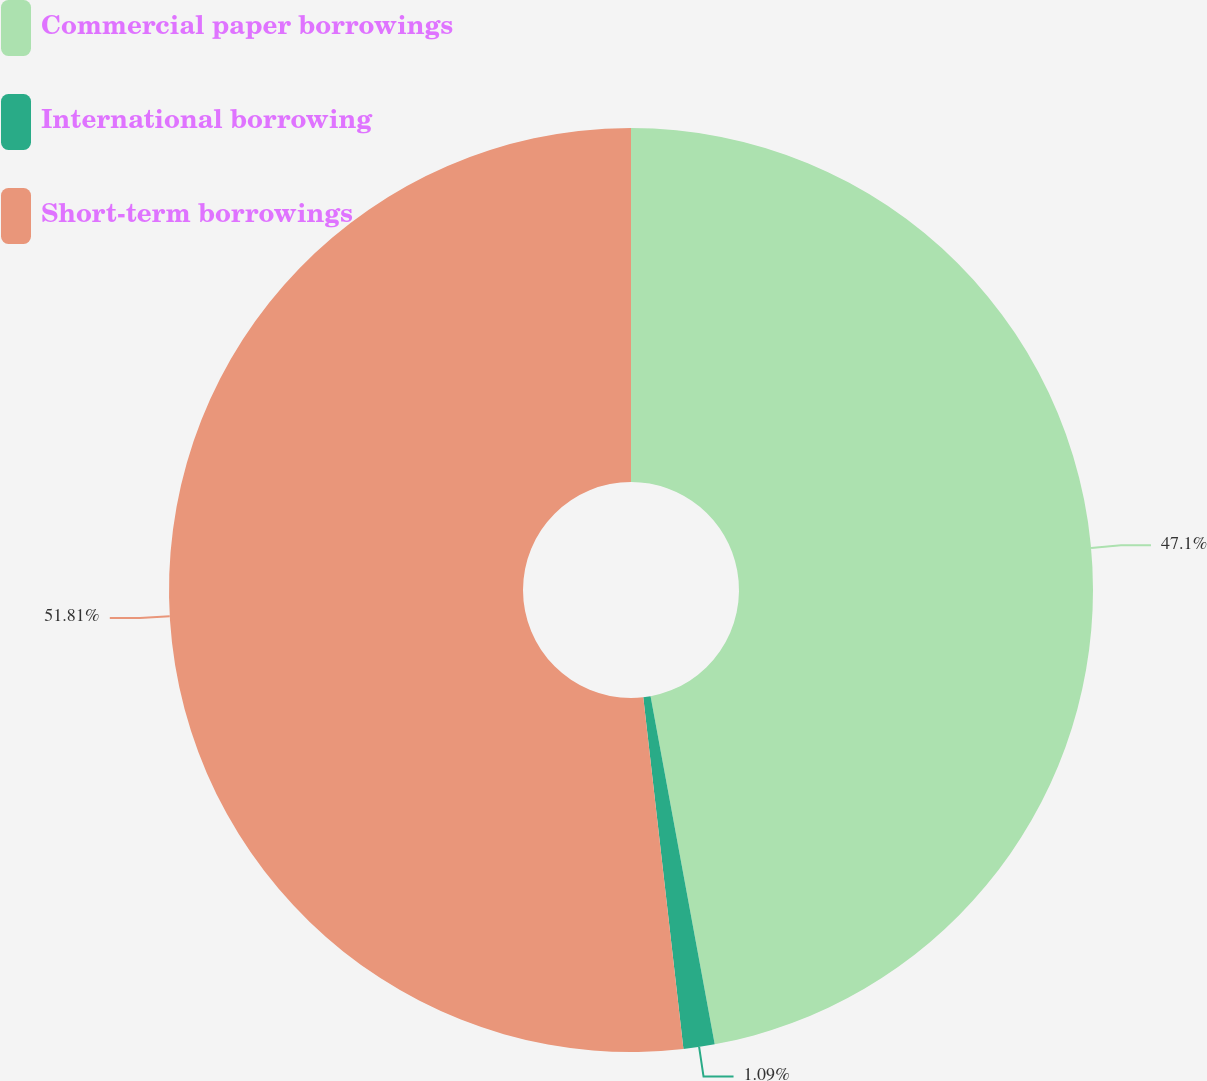Convert chart to OTSL. <chart><loc_0><loc_0><loc_500><loc_500><pie_chart><fcel>Commercial paper borrowings<fcel>International borrowing<fcel>Short-term borrowings<nl><fcel>47.1%<fcel>1.09%<fcel>51.81%<nl></chart> 